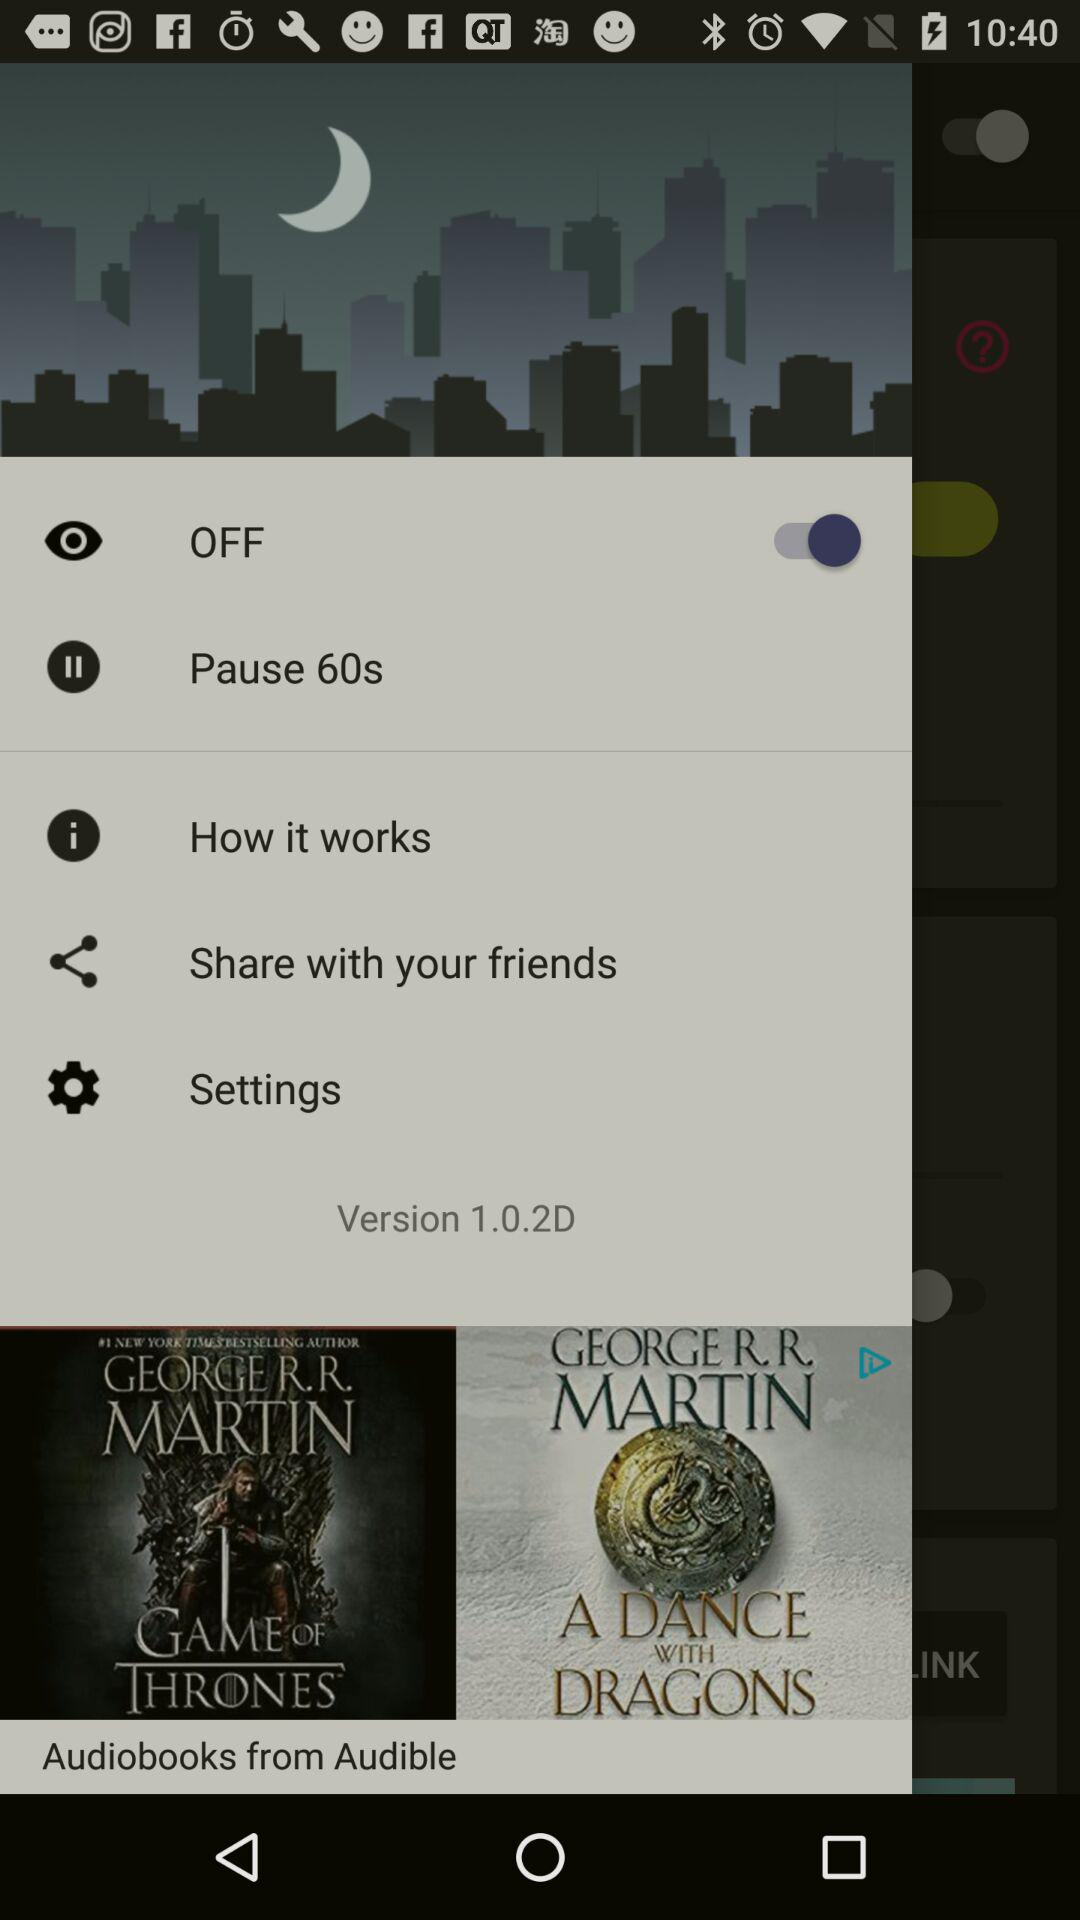What is the status of "OFF"? The status is "on". 